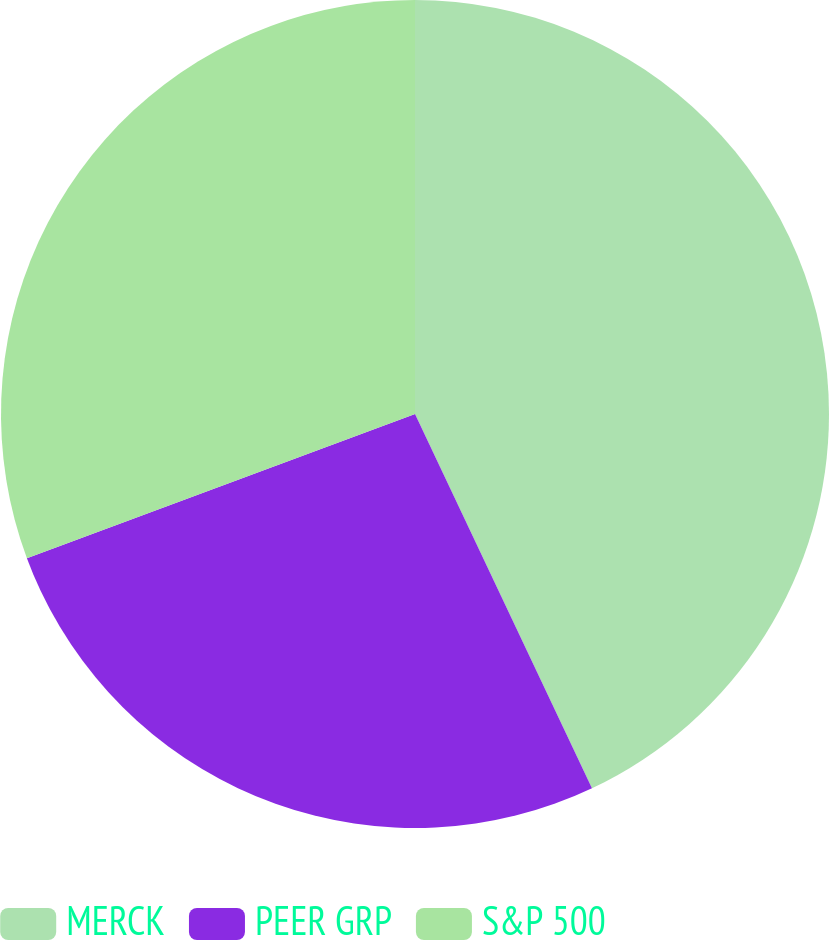Convert chart. <chart><loc_0><loc_0><loc_500><loc_500><pie_chart><fcel>MERCK<fcel>PEER GRP<fcel>S&P 500<nl><fcel>42.97%<fcel>26.37%<fcel>30.66%<nl></chart> 